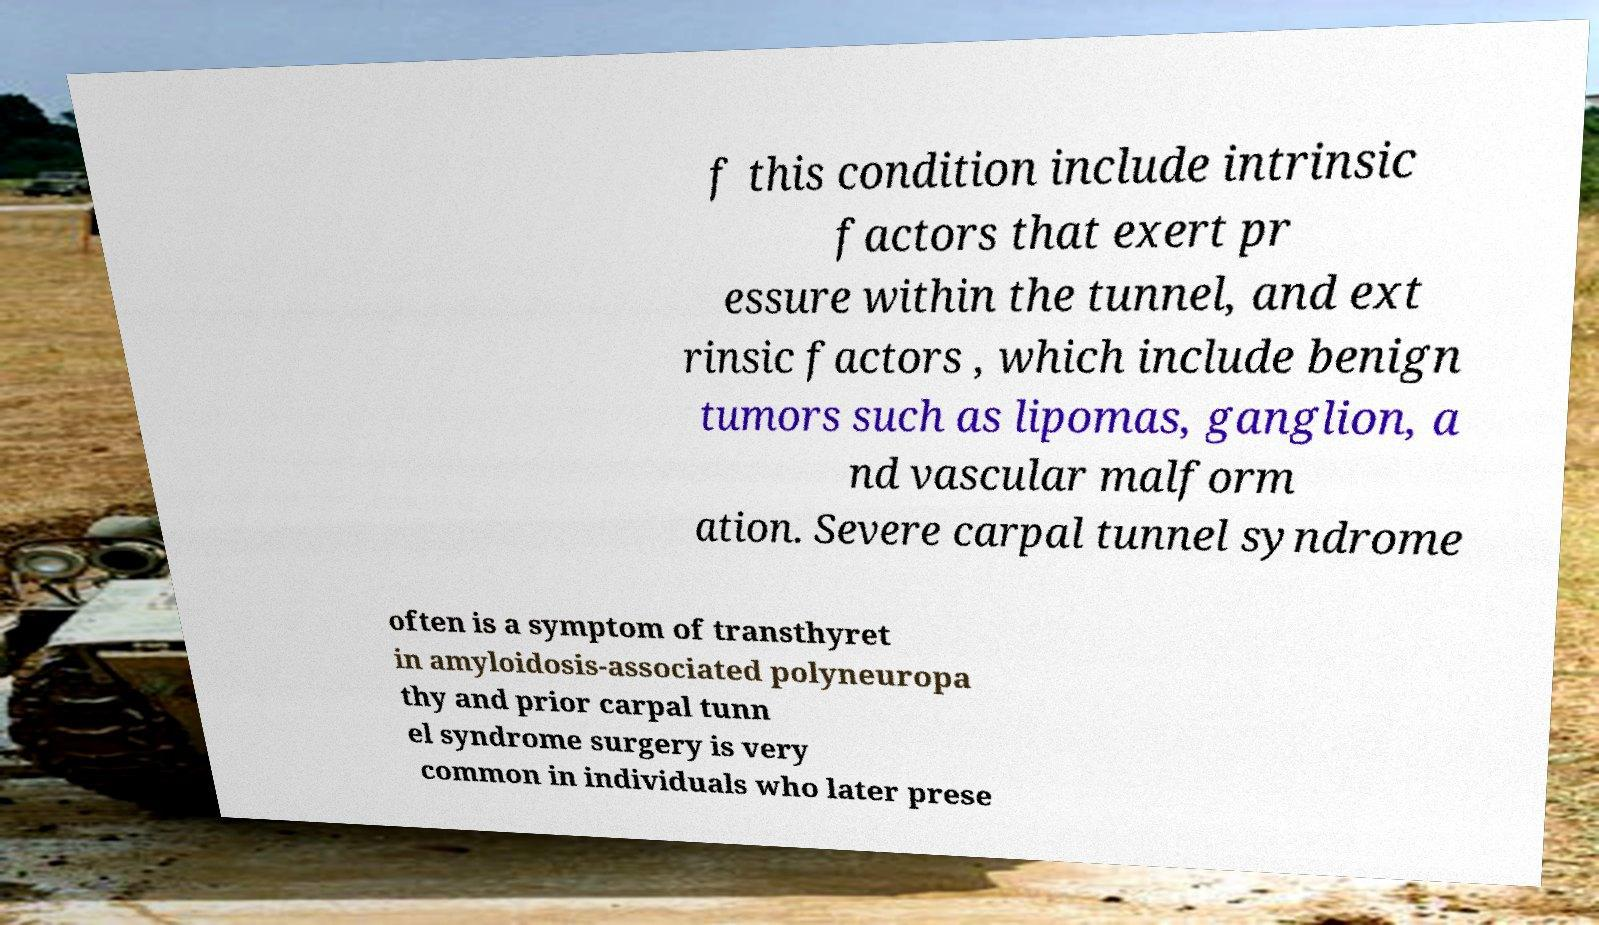Could you assist in decoding the text presented in this image and type it out clearly? f this condition include intrinsic factors that exert pr essure within the tunnel, and ext rinsic factors , which include benign tumors such as lipomas, ganglion, a nd vascular malform ation. Severe carpal tunnel syndrome often is a symptom of transthyret in amyloidosis-associated polyneuropa thy and prior carpal tunn el syndrome surgery is very common in individuals who later prese 